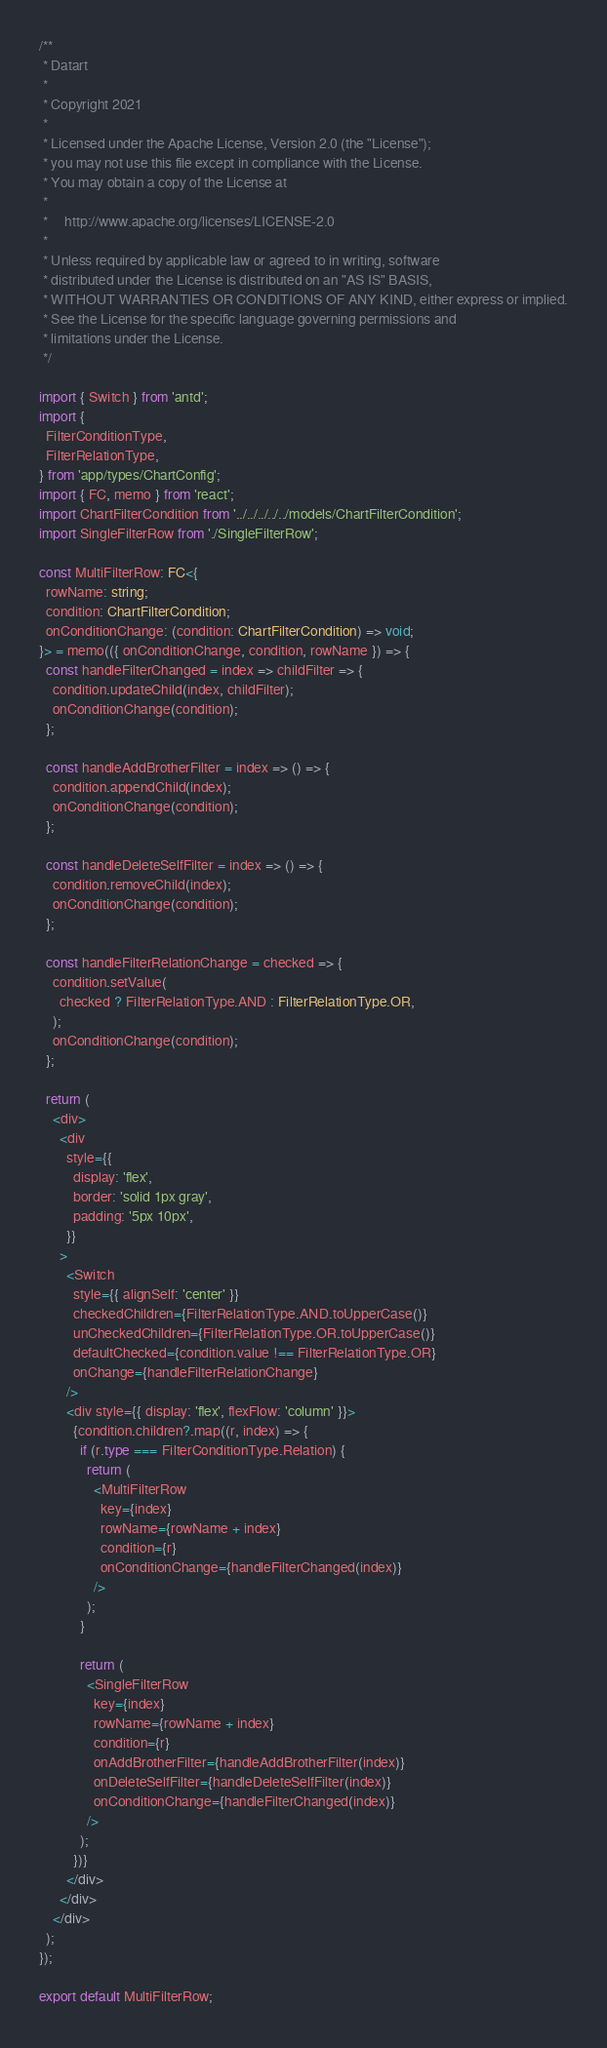Convert code to text. <code><loc_0><loc_0><loc_500><loc_500><_TypeScript_>/**
 * Datart
 *
 * Copyright 2021
 *
 * Licensed under the Apache License, Version 2.0 (the "License");
 * you may not use this file except in compliance with the License.
 * You may obtain a copy of the License at
 *
 *     http://www.apache.org/licenses/LICENSE-2.0
 *
 * Unless required by applicable law or agreed to in writing, software
 * distributed under the License is distributed on an "AS IS" BASIS,
 * WITHOUT WARRANTIES OR CONDITIONS OF ANY KIND, either express or implied.
 * See the License for the specific language governing permissions and
 * limitations under the License.
 */

import { Switch } from 'antd';
import {
  FilterConditionType,
  FilterRelationType,
} from 'app/types/ChartConfig';
import { FC, memo } from 'react';
import ChartFilterCondition from '../../../../../models/ChartFilterCondition';
import SingleFilterRow from './SingleFilterRow';

const MultiFilterRow: FC<{
  rowName: string;
  condition: ChartFilterCondition;
  onConditionChange: (condition: ChartFilterCondition) => void;
}> = memo(({ onConditionChange, condition, rowName }) => {
  const handleFilterChanged = index => childFilter => {
    condition.updateChild(index, childFilter);
    onConditionChange(condition);
  };

  const handleAddBrotherFilter = index => () => {
    condition.appendChild(index);
    onConditionChange(condition);
  };

  const handleDeleteSelfFilter = index => () => {
    condition.removeChild(index);
    onConditionChange(condition);
  };

  const handleFilterRelationChange = checked => {
    condition.setValue(
      checked ? FilterRelationType.AND : FilterRelationType.OR,
    );
    onConditionChange(condition);
  };

  return (
    <div>
      <div
        style={{
          display: 'flex',
          border: 'solid 1px gray',
          padding: '5px 10px',
        }}
      >
        <Switch
          style={{ alignSelf: 'center' }}
          checkedChildren={FilterRelationType.AND.toUpperCase()}
          unCheckedChildren={FilterRelationType.OR.toUpperCase()}
          defaultChecked={condition.value !== FilterRelationType.OR}
          onChange={handleFilterRelationChange}
        />
        <div style={{ display: 'flex', flexFlow: 'column' }}>
          {condition.children?.map((r, index) => {
            if (r.type === FilterConditionType.Relation) {
              return (
                <MultiFilterRow
                  key={index}
                  rowName={rowName + index}
                  condition={r}
                  onConditionChange={handleFilterChanged(index)}
                />
              );
            }

            return (
              <SingleFilterRow
                key={index}
                rowName={rowName + index}
                condition={r}
                onAddBrotherFilter={handleAddBrotherFilter(index)}
                onDeleteSelfFilter={handleDeleteSelfFilter(index)}
                onConditionChange={handleFilterChanged(index)}
              />
            );
          })}
        </div>
      </div>
    </div>
  );
});

export default MultiFilterRow;
</code> 